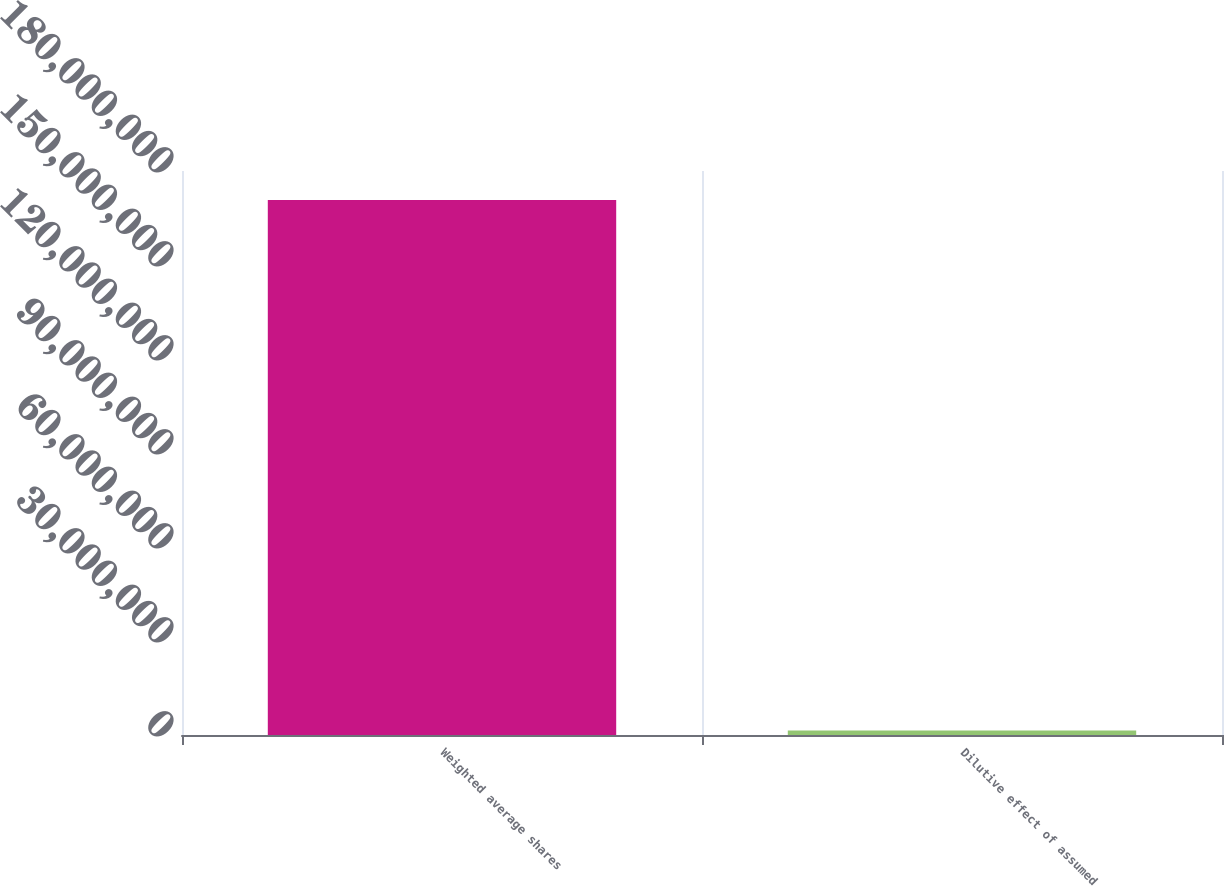Convert chart to OTSL. <chart><loc_0><loc_0><loc_500><loc_500><bar_chart><fcel>Weighted average shares<fcel>Dilutive effect of assumed<nl><fcel>1.70754e+08<fcel>1.405e+06<nl></chart> 